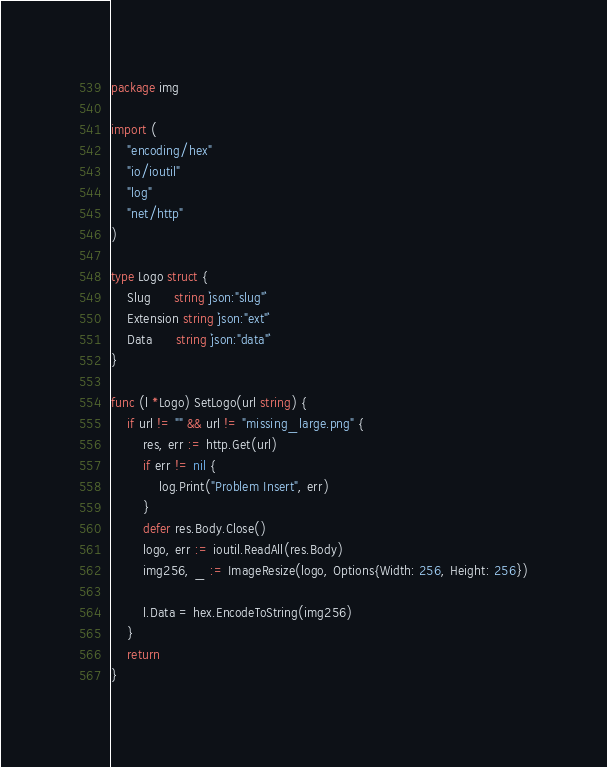<code> <loc_0><loc_0><loc_500><loc_500><_Go_>package img

import (
	"encoding/hex"
	"io/ioutil"
	"log"
	"net/http"
)

type Logo struct {
	Slug      string `json:"slug"`
	Extension string `json:"ext"`
	Data      string `json:"data"`
}

func (l *Logo) SetLogo(url string) {
	if url != "" && url != "missing_large.png" {
		res, err := http.Get(url)
		if err != nil {
			log.Print("Problem Insert", err)
		}
		defer res.Body.Close()
		logo, err := ioutil.ReadAll(res.Body)
		img256, _ := ImageResize(logo, Options{Width: 256, Height: 256})

		l.Data = hex.EncodeToString(img256)
	}
	return
}
</code> 